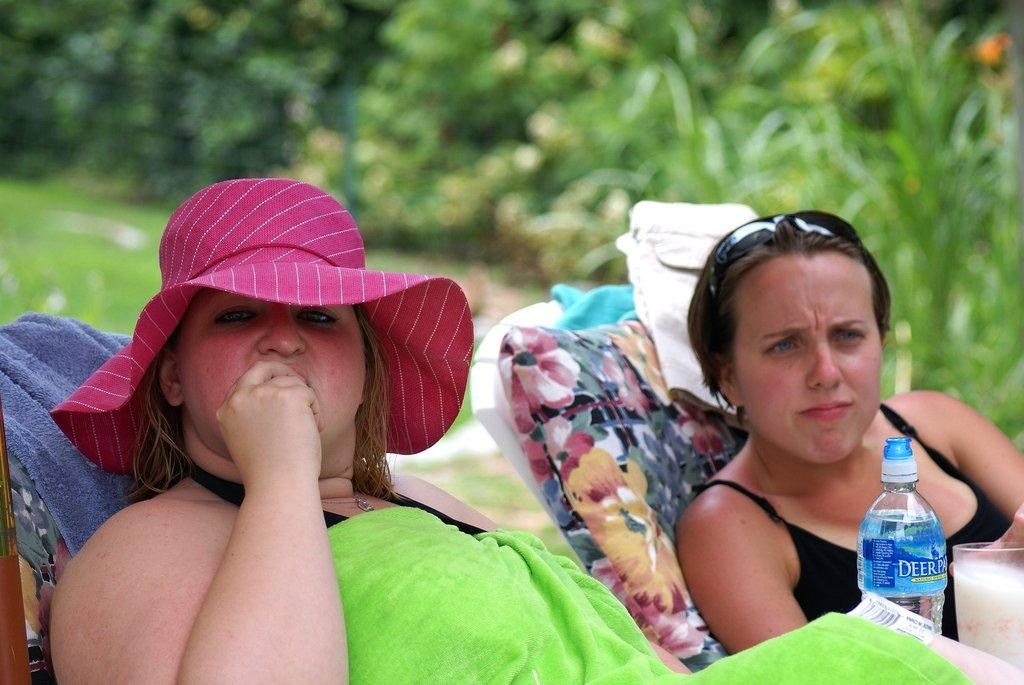How many women are in the image? There are two women in the image. What are the women doing in the image? The women are sitting on a chair in the image. What objects can be seen near the women? There is a bottle, a glass, and a towel in the image. What can be seen in the background of the image? There are trees in the background of the image. What type of insurance policy is being discussed by the women in the image? There is no indication in the image that the women are discussing any insurance policies. 